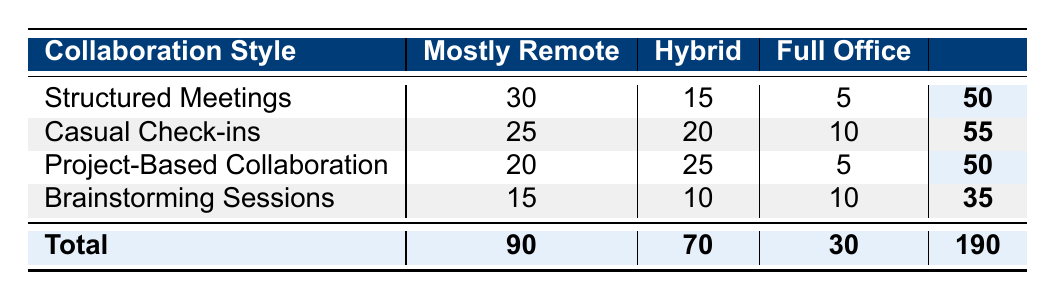What is the total number of respondents preferring "Mostly Remote"? To find the total number of respondents who prefer "Mostly Remote," we look at the "Mostly Remote" column and sum the counts for all collaboration styles: 30 (Structured Meetings) + 25 (Casual Check-ins) + 20 (Project-Based Collaboration) + 15 (Brainstorming Sessions) = 90.
Answer: 90 Which collaboration style has the highest preference for "Hybrid"? To determine which collaboration style has the highest preference for "Hybrid," we compare the counts in the "Hybrid" column: 15 (Structured Meetings), 20 (Casual Check-ins), 25 (Project-Based Collaboration), and 10 (Brainstorming Sessions). The highest count is 25 from Project-Based Collaboration.
Answer: Project-Based Collaboration Is the total number of respondents preferring "Full Office" greater than 30? To find this, we sum the "Full Office" values: 5 (Structured Meetings) + 10 (Casual Check-ins) + 5 (Project-Based Collaboration) + 10 (Brainstorming Sessions) = 30. Since 30 is not greater than 30, the statement is false.
Answer: No What is the difference in preference counts between "Mostly Remote" and "Full Office" for Casual Check-ins? For Casual Check-ins, the count for "Mostly Remote" is 25 and for "Full Office" is 10. The difference is calculated as 25 - 10 = 15.
Answer: 15 Which collaboration style has the least total count and what is that total? To find the collaboration style with the least total, we add the counts for each style: Structured Meetings = 50, Casual Check-ins = 55, Project-Based Collaboration = 50, and Brainstorming Sessions = 35. The least total is 35 from Brainstorming Sessions.
Answer: Brainstorming Sessions, 35 